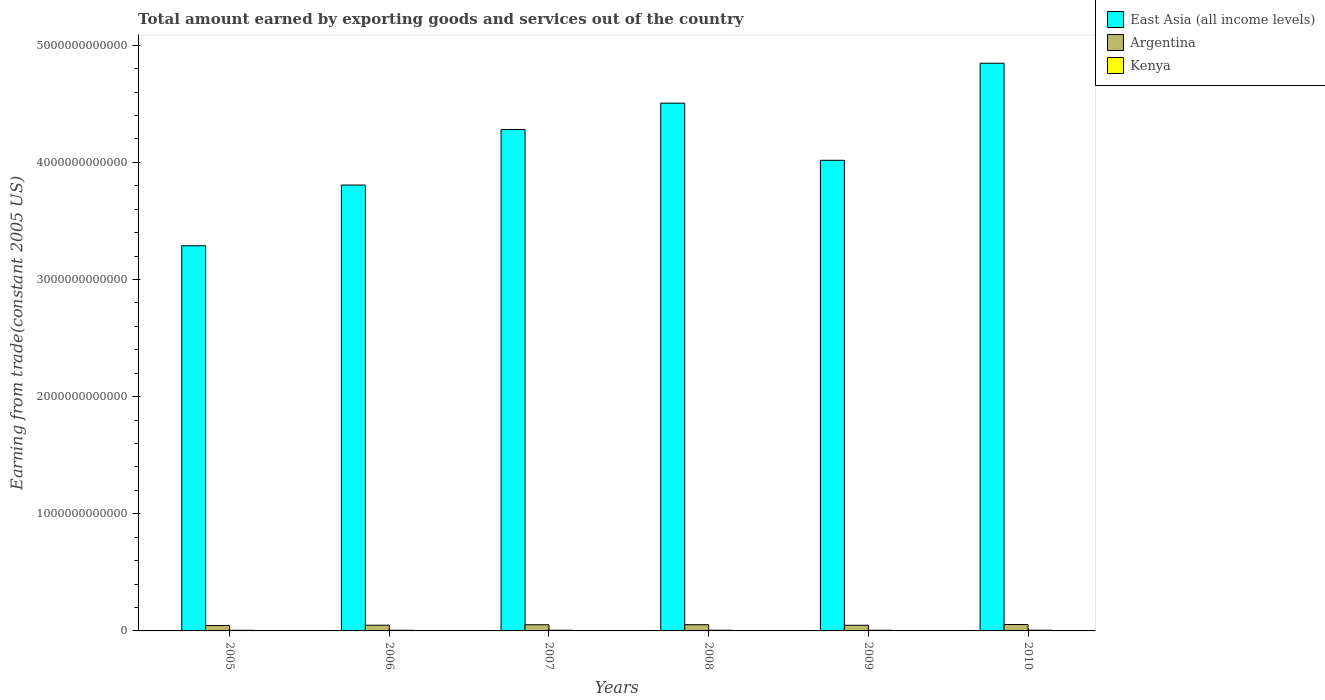How many different coloured bars are there?
Make the answer very short. 3. How many bars are there on the 4th tick from the left?
Offer a very short reply. 3. In how many cases, is the number of bars for a given year not equal to the number of legend labels?
Provide a short and direct response. 0. What is the total amount earned by exporting goods and services in East Asia (all income levels) in 2005?
Give a very brief answer. 3.29e+12. Across all years, what is the maximum total amount earned by exporting goods and services in Kenya?
Your response must be concise. 6.20e+09. Across all years, what is the minimum total amount earned by exporting goods and services in East Asia (all income levels)?
Ensure brevity in your answer.  3.29e+12. In which year was the total amount earned by exporting goods and services in Argentina maximum?
Offer a terse response. 2010. In which year was the total amount earned by exporting goods and services in East Asia (all income levels) minimum?
Offer a terse response. 2005. What is the total total amount earned by exporting goods and services in Kenya in the graph?
Your response must be concise. 3.46e+1. What is the difference between the total amount earned by exporting goods and services in Kenya in 2007 and that in 2008?
Keep it short and to the point. -1.39e+08. What is the difference between the total amount earned by exporting goods and services in Argentina in 2007 and the total amount earned by exporting goods and services in Kenya in 2010?
Provide a short and direct response. 4.64e+1. What is the average total amount earned by exporting goods and services in Kenya per year?
Your answer should be compact. 5.77e+09. In the year 2007, what is the difference between the total amount earned by exporting goods and services in East Asia (all income levels) and total amount earned by exporting goods and services in Argentina?
Keep it short and to the point. 4.23e+12. In how many years, is the total amount earned by exporting goods and services in East Asia (all income levels) greater than 2800000000000 US$?
Your answer should be compact. 6. What is the ratio of the total amount earned by exporting goods and services in Kenya in 2006 to that in 2009?
Offer a terse response. 0.97. What is the difference between the highest and the second highest total amount earned by exporting goods and services in Argentina?
Keep it short and to the point. 1.76e+09. What is the difference between the highest and the lowest total amount earned by exporting goods and services in East Asia (all income levels)?
Your response must be concise. 1.56e+12. Is the sum of the total amount earned by exporting goods and services in East Asia (all income levels) in 2006 and 2009 greater than the maximum total amount earned by exporting goods and services in Argentina across all years?
Ensure brevity in your answer.  Yes. What does the 2nd bar from the left in 2007 represents?
Your answer should be compact. Argentina. What does the 3rd bar from the right in 2007 represents?
Make the answer very short. East Asia (all income levels). How many bars are there?
Ensure brevity in your answer.  18. What is the difference between two consecutive major ticks on the Y-axis?
Your response must be concise. 1.00e+12. Are the values on the major ticks of Y-axis written in scientific E-notation?
Provide a succinct answer. No. How many legend labels are there?
Your answer should be compact. 3. What is the title of the graph?
Offer a very short reply. Total amount earned by exporting goods and services out of the country. What is the label or title of the X-axis?
Offer a terse response. Years. What is the label or title of the Y-axis?
Provide a succinct answer. Earning from trade(constant 2005 US). What is the Earning from trade(constant 2005 US) in East Asia (all income levels) in 2005?
Your response must be concise. 3.29e+12. What is the Earning from trade(constant 2005 US) of Argentina in 2005?
Keep it short and to the point. 4.62e+1. What is the Earning from trade(constant 2005 US) of Kenya in 2005?
Give a very brief answer. 5.34e+09. What is the Earning from trade(constant 2005 US) in East Asia (all income levels) in 2006?
Ensure brevity in your answer.  3.81e+12. What is the Earning from trade(constant 2005 US) of Argentina in 2006?
Keep it short and to the point. 4.88e+1. What is the Earning from trade(constant 2005 US) in Kenya in 2006?
Keep it short and to the point. 5.53e+09. What is the Earning from trade(constant 2005 US) in East Asia (all income levels) in 2007?
Offer a terse response. 4.28e+12. What is the Earning from trade(constant 2005 US) in Argentina in 2007?
Offer a terse response. 5.26e+1. What is the Earning from trade(constant 2005 US) in Kenya in 2007?
Offer a very short reply. 5.87e+09. What is the Earning from trade(constant 2005 US) in East Asia (all income levels) in 2008?
Make the answer very short. 4.51e+12. What is the Earning from trade(constant 2005 US) of Argentina in 2008?
Your answer should be compact. 5.32e+1. What is the Earning from trade(constant 2005 US) of Kenya in 2008?
Your answer should be compact. 6.01e+09. What is the Earning from trade(constant 2005 US) of East Asia (all income levels) in 2009?
Ensure brevity in your answer.  4.02e+12. What is the Earning from trade(constant 2005 US) of Argentina in 2009?
Make the answer very short. 4.82e+1. What is the Earning from trade(constant 2005 US) in Kenya in 2009?
Give a very brief answer. 5.70e+09. What is the Earning from trade(constant 2005 US) of East Asia (all income levels) in 2010?
Provide a short and direct response. 4.85e+12. What is the Earning from trade(constant 2005 US) in Argentina in 2010?
Provide a short and direct response. 5.49e+1. What is the Earning from trade(constant 2005 US) of Kenya in 2010?
Your answer should be compact. 6.20e+09. Across all years, what is the maximum Earning from trade(constant 2005 US) of East Asia (all income levels)?
Give a very brief answer. 4.85e+12. Across all years, what is the maximum Earning from trade(constant 2005 US) of Argentina?
Your answer should be compact. 5.49e+1. Across all years, what is the maximum Earning from trade(constant 2005 US) of Kenya?
Provide a succinct answer. 6.20e+09. Across all years, what is the minimum Earning from trade(constant 2005 US) in East Asia (all income levels)?
Offer a very short reply. 3.29e+12. Across all years, what is the minimum Earning from trade(constant 2005 US) in Argentina?
Ensure brevity in your answer.  4.62e+1. Across all years, what is the minimum Earning from trade(constant 2005 US) of Kenya?
Provide a short and direct response. 5.34e+09. What is the total Earning from trade(constant 2005 US) of East Asia (all income levels) in the graph?
Offer a terse response. 2.47e+13. What is the total Earning from trade(constant 2005 US) of Argentina in the graph?
Provide a succinct answer. 3.04e+11. What is the total Earning from trade(constant 2005 US) in Kenya in the graph?
Your response must be concise. 3.46e+1. What is the difference between the Earning from trade(constant 2005 US) of East Asia (all income levels) in 2005 and that in 2006?
Make the answer very short. -5.18e+11. What is the difference between the Earning from trade(constant 2005 US) of Argentina in 2005 and that in 2006?
Offer a very short reply. -2.61e+09. What is the difference between the Earning from trade(constant 2005 US) of Kenya in 2005 and that in 2006?
Provide a succinct answer. -1.89e+08. What is the difference between the Earning from trade(constant 2005 US) in East Asia (all income levels) in 2005 and that in 2007?
Your response must be concise. -9.92e+11. What is the difference between the Earning from trade(constant 2005 US) in Argentina in 2005 and that in 2007?
Your answer should be very brief. -6.45e+09. What is the difference between the Earning from trade(constant 2005 US) in Kenya in 2005 and that in 2007?
Your response must be concise. -5.30e+08. What is the difference between the Earning from trade(constant 2005 US) in East Asia (all income levels) in 2005 and that in 2008?
Your response must be concise. -1.22e+12. What is the difference between the Earning from trade(constant 2005 US) of Argentina in 2005 and that in 2008?
Keep it short and to the point. -7.02e+09. What is the difference between the Earning from trade(constant 2005 US) of Kenya in 2005 and that in 2008?
Your answer should be compact. -6.69e+08. What is the difference between the Earning from trade(constant 2005 US) of East Asia (all income levels) in 2005 and that in 2009?
Your answer should be very brief. -7.29e+11. What is the difference between the Earning from trade(constant 2005 US) in Argentina in 2005 and that in 2009?
Keep it short and to the point. -2.03e+09. What is the difference between the Earning from trade(constant 2005 US) of Kenya in 2005 and that in 2009?
Provide a short and direct response. -3.55e+08. What is the difference between the Earning from trade(constant 2005 US) of East Asia (all income levels) in 2005 and that in 2010?
Keep it short and to the point. -1.56e+12. What is the difference between the Earning from trade(constant 2005 US) in Argentina in 2005 and that in 2010?
Ensure brevity in your answer.  -8.78e+09. What is the difference between the Earning from trade(constant 2005 US) of Kenya in 2005 and that in 2010?
Your answer should be very brief. -8.53e+08. What is the difference between the Earning from trade(constant 2005 US) of East Asia (all income levels) in 2006 and that in 2007?
Give a very brief answer. -4.74e+11. What is the difference between the Earning from trade(constant 2005 US) of Argentina in 2006 and that in 2007?
Keep it short and to the point. -3.84e+09. What is the difference between the Earning from trade(constant 2005 US) in Kenya in 2006 and that in 2007?
Ensure brevity in your answer.  -3.41e+08. What is the difference between the Earning from trade(constant 2005 US) of East Asia (all income levels) in 2006 and that in 2008?
Provide a succinct answer. -6.99e+11. What is the difference between the Earning from trade(constant 2005 US) of Argentina in 2006 and that in 2008?
Offer a very short reply. -4.41e+09. What is the difference between the Earning from trade(constant 2005 US) of Kenya in 2006 and that in 2008?
Your answer should be compact. -4.80e+08. What is the difference between the Earning from trade(constant 2005 US) in East Asia (all income levels) in 2006 and that in 2009?
Offer a terse response. -2.11e+11. What is the difference between the Earning from trade(constant 2005 US) in Argentina in 2006 and that in 2009?
Ensure brevity in your answer.  5.84e+08. What is the difference between the Earning from trade(constant 2005 US) of Kenya in 2006 and that in 2009?
Offer a very short reply. -1.66e+08. What is the difference between the Earning from trade(constant 2005 US) in East Asia (all income levels) in 2006 and that in 2010?
Your answer should be very brief. -1.04e+12. What is the difference between the Earning from trade(constant 2005 US) of Argentina in 2006 and that in 2010?
Offer a very short reply. -6.17e+09. What is the difference between the Earning from trade(constant 2005 US) of Kenya in 2006 and that in 2010?
Your answer should be compact. -6.64e+08. What is the difference between the Earning from trade(constant 2005 US) in East Asia (all income levels) in 2007 and that in 2008?
Your answer should be compact. -2.25e+11. What is the difference between the Earning from trade(constant 2005 US) in Argentina in 2007 and that in 2008?
Keep it short and to the point. -5.74e+08. What is the difference between the Earning from trade(constant 2005 US) in Kenya in 2007 and that in 2008?
Make the answer very short. -1.39e+08. What is the difference between the Earning from trade(constant 2005 US) in East Asia (all income levels) in 2007 and that in 2009?
Offer a very short reply. 2.62e+11. What is the difference between the Earning from trade(constant 2005 US) in Argentina in 2007 and that in 2009?
Your answer should be very brief. 4.43e+09. What is the difference between the Earning from trade(constant 2005 US) of Kenya in 2007 and that in 2009?
Provide a short and direct response. 1.74e+08. What is the difference between the Earning from trade(constant 2005 US) in East Asia (all income levels) in 2007 and that in 2010?
Give a very brief answer. -5.66e+11. What is the difference between the Earning from trade(constant 2005 US) in Argentina in 2007 and that in 2010?
Give a very brief answer. -2.33e+09. What is the difference between the Earning from trade(constant 2005 US) in Kenya in 2007 and that in 2010?
Keep it short and to the point. -3.24e+08. What is the difference between the Earning from trade(constant 2005 US) in East Asia (all income levels) in 2008 and that in 2009?
Offer a very short reply. 4.88e+11. What is the difference between the Earning from trade(constant 2005 US) of Argentina in 2008 and that in 2009?
Your response must be concise. 5.00e+09. What is the difference between the Earning from trade(constant 2005 US) in Kenya in 2008 and that in 2009?
Offer a terse response. 3.14e+08. What is the difference between the Earning from trade(constant 2005 US) of East Asia (all income levels) in 2008 and that in 2010?
Your response must be concise. -3.41e+11. What is the difference between the Earning from trade(constant 2005 US) in Argentina in 2008 and that in 2010?
Your response must be concise. -1.76e+09. What is the difference between the Earning from trade(constant 2005 US) of Kenya in 2008 and that in 2010?
Make the answer very short. -1.84e+08. What is the difference between the Earning from trade(constant 2005 US) of East Asia (all income levels) in 2009 and that in 2010?
Give a very brief answer. -8.28e+11. What is the difference between the Earning from trade(constant 2005 US) in Argentina in 2009 and that in 2010?
Make the answer very short. -6.76e+09. What is the difference between the Earning from trade(constant 2005 US) in Kenya in 2009 and that in 2010?
Your answer should be very brief. -4.98e+08. What is the difference between the Earning from trade(constant 2005 US) of East Asia (all income levels) in 2005 and the Earning from trade(constant 2005 US) of Argentina in 2006?
Provide a short and direct response. 3.24e+12. What is the difference between the Earning from trade(constant 2005 US) of East Asia (all income levels) in 2005 and the Earning from trade(constant 2005 US) of Kenya in 2006?
Your response must be concise. 3.28e+12. What is the difference between the Earning from trade(constant 2005 US) of Argentina in 2005 and the Earning from trade(constant 2005 US) of Kenya in 2006?
Keep it short and to the point. 4.06e+1. What is the difference between the Earning from trade(constant 2005 US) of East Asia (all income levels) in 2005 and the Earning from trade(constant 2005 US) of Argentina in 2007?
Your answer should be very brief. 3.24e+12. What is the difference between the Earning from trade(constant 2005 US) of East Asia (all income levels) in 2005 and the Earning from trade(constant 2005 US) of Kenya in 2007?
Provide a succinct answer. 3.28e+12. What is the difference between the Earning from trade(constant 2005 US) of Argentina in 2005 and the Earning from trade(constant 2005 US) of Kenya in 2007?
Your answer should be compact. 4.03e+1. What is the difference between the Earning from trade(constant 2005 US) in East Asia (all income levels) in 2005 and the Earning from trade(constant 2005 US) in Argentina in 2008?
Your answer should be very brief. 3.24e+12. What is the difference between the Earning from trade(constant 2005 US) of East Asia (all income levels) in 2005 and the Earning from trade(constant 2005 US) of Kenya in 2008?
Offer a terse response. 3.28e+12. What is the difference between the Earning from trade(constant 2005 US) of Argentina in 2005 and the Earning from trade(constant 2005 US) of Kenya in 2008?
Give a very brief answer. 4.01e+1. What is the difference between the Earning from trade(constant 2005 US) of East Asia (all income levels) in 2005 and the Earning from trade(constant 2005 US) of Argentina in 2009?
Offer a very short reply. 3.24e+12. What is the difference between the Earning from trade(constant 2005 US) in East Asia (all income levels) in 2005 and the Earning from trade(constant 2005 US) in Kenya in 2009?
Your answer should be very brief. 3.28e+12. What is the difference between the Earning from trade(constant 2005 US) of Argentina in 2005 and the Earning from trade(constant 2005 US) of Kenya in 2009?
Your response must be concise. 4.05e+1. What is the difference between the Earning from trade(constant 2005 US) in East Asia (all income levels) in 2005 and the Earning from trade(constant 2005 US) in Argentina in 2010?
Keep it short and to the point. 3.23e+12. What is the difference between the Earning from trade(constant 2005 US) of East Asia (all income levels) in 2005 and the Earning from trade(constant 2005 US) of Kenya in 2010?
Offer a very short reply. 3.28e+12. What is the difference between the Earning from trade(constant 2005 US) in Argentina in 2005 and the Earning from trade(constant 2005 US) in Kenya in 2010?
Your answer should be very brief. 4.00e+1. What is the difference between the Earning from trade(constant 2005 US) in East Asia (all income levels) in 2006 and the Earning from trade(constant 2005 US) in Argentina in 2007?
Your answer should be very brief. 3.75e+12. What is the difference between the Earning from trade(constant 2005 US) of East Asia (all income levels) in 2006 and the Earning from trade(constant 2005 US) of Kenya in 2007?
Your answer should be very brief. 3.80e+12. What is the difference between the Earning from trade(constant 2005 US) in Argentina in 2006 and the Earning from trade(constant 2005 US) in Kenya in 2007?
Provide a succinct answer. 4.29e+1. What is the difference between the Earning from trade(constant 2005 US) in East Asia (all income levels) in 2006 and the Earning from trade(constant 2005 US) in Argentina in 2008?
Offer a very short reply. 3.75e+12. What is the difference between the Earning from trade(constant 2005 US) in East Asia (all income levels) in 2006 and the Earning from trade(constant 2005 US) in Kenya in 2008?
Offer a terse response. 3.80e+12. What is the difference between the Earning from trade(constant 2005 US) of Argentina in 2006 and the Earning from trade(constant 2005 US) of Kenya in 2008?
Your response must be concise. 4.28e+1. What is the difference between the Earning from trade(constant 2005 US) in East Asia (all income levels) in 2006 and the Earning from trade(constant 2005 US) in Argentina in 2009?
Offer a very short reply. 3.76e+12. What is the difference between the Earning from trade(constant 2005 US) of East Asia (all income levels) in 2006 and the Earning from trade(constant 2005 US) of Kenya in 2009?
Offer a terse response. 3.80e+12. What is the difference between the Earning from trade(constant 2005 US) in Argentina in 2006 and the Earning from trade(constant 2005 US) in Kenya in 2009?
Your answer should be very brief. 4.31e+1. What is the difference between the Earning from trade(constant 2005 US) in East Asia (all income levels) in 2006 and the Earning from trade(constant 2005 US) in Argentina in 2010?
Offer a very short reply. 3.75e+12. What is the difference between the Earning from trade(constant 2005 US) of East Asia (all income levels) in 2006 and the Earning from trade(constant 2005 US) of Kenya in 2010?
Your response must be concise. 3.80e+12. What is the difference between the Earning from trade(constant 2005 US) of Argentina in 2006 and the Earning from trade(constant 2005 US) of Kenya in 2010?
Give a very brief answer. 4.26e+1. What is the difference between the Earning from trade(constant 2005 US) of East Asia (all income levels) in 2007 and the Earning from trade(constant 2005 US) of Argentina in 2008?
Give a very brief answer. 4.23e+12. What is the difference between the Earning from trade(constant 2005 US) of East Asia (all income levels) in 2007 and the Earning from trade(constant 2005 US) of Kenya in 2008?
Make the answer very short. 4.27e+12. What is the difference between the Earning from trade(constant 2005 US) of Argentina in 2007 and the Earning from trade(constant 2005 US) of Kenya in 2008?
Your answer should be very brief. 4.66e+1. What is the difference between the Earning from trade(constant 2005 US) in East Asia (all income levels) in 2007 and the Earning from trade(constant 2005 US) in Argentina in 2009?
Offer a very short reply. 4.23e+12. What is the difference between the Earning from trade(constant 2005 US) in East Asia (all income levels) in 2007 and the Earning from trade(constant 2005 US) in Kenya in 2009?
Provide a succinct answer. 4.27e+12. What is the difference between the Earning from trade(constant 2005 US) in Argentina in 2007 and the Earning from trade(constant 2005 US) in Kenya in 2009?
Your answer should be compact. 4.69e+1. What is the difference between the Earning from trade(constant 2005 US) in East Asia (all income levels) in 2007 and the Earning from trade(constant 2005 US) in Argentina in 2010?
Your answer should be very brief. 4.23e+12. What is the difference between the Earning from trade(constant 2005 US) of East Asia (all income levels) in 2007 and the Earning from trade(constant 2005 US) of Kenya in 2010?
Provide a succinct answer. 4.27e+12. What is the difference between the Earning from trade(constant 2005 US) in Argentina in 2007 and the Earning from trade(constant 2005 US) in Kenya in 2010?
Provide a short and direct response. 4.64e+1. What is the difference between the Earning from trade(constant 2005 US) in East Asia (all income levels) in 2008 and the Earning from trade(constant 2005 US) in Argentina in 2009?
Make the answer very short. 4.46e+12. What is the difference between the Earning from trade(constant 2005 US) of East Asia (all income levels) in 2008 and the Earning from trade(constant 2005 US) of Kenya in 2009?
Make the answer very short. 4.50e+12. What is the difference between the Earning from trade(constant 2005 US) of Argentina in 2008 and the Earning from trade(constant 2005 US) of Kenya in 2009?
Ensure brevity in your answer.  4.75e+1. What is the difference between the Earning from trade(constant 2005 US) of East Asia (all income levels) in 2008 and the Earning from trade(constant 2005 US) of Argentina in 2010?
Your response must be concise. 4.45e+12. What is the difference between the Earning from trade(constant 2005 US) of East Asia (all income levels) in 2008 and the Earning from trade(constant 2005 US) of Kenya in 2010?
Ensure brevity in your answer.  4.50e+12. What is the difference between the Earning from trade(constant 2005 US) of Argentina in 2008 and the Earning from trade(constant 2005 US) of Kenya in 2010?
Ensure brevity in your answer.  4.70e+1. What is the difference between the Earning from trade(constant 2005 US) of East Asia (all income levels) in 2009 and the Earning from trade(constant 2005 US) of Argentina in 2010?
Give a very brief answer. 3.96e+12. What is the difference between the Earning from trade(constant 2005 US) of East Asia (all income levels) in 2009 and the Earning from trade(constant 2005 US) of Kenya in 2010?
Give a very brief answer. 4.01e+12. What is the difference between the Earning from trade(constant 2005 US) of Argentina in 2009 and the Earning from trade(constant 2005 US) of Kenya in 2010?
Keep it short and to the point. 4.20e+1. What is the average Earning from trade(constant 2005 US) in East Asia (all income levels) per year?
Your answer should be compact. 4.12e+12. What is the average Earning from trade(constant 2005 US) of Argentina per year?
Keep it short and to the point. 5.06e+1. What is the average Earning from trade(constant 2005 US) in Kenya per year?
Keep it short and to the point. 5.77e+09. In the year 2005, what is the difference between the Earning from trade(constant 2005 US) of East Asia (all income levels) and Earning from trade(constant 2005 US) of Argentina?
Your answer should be very brief. 3.24e+12. In the year 2005, what is the difference between the Earning from trade(constant 2005 US) of East Asia (all income levels) and Earning from trade(constant 2005 US) of Kenya?
Give a very brief answer. 3.28e+12. In the year 2005, what is the difference between the Earning from trade(constant 2005 US) of Argentina and Earning from trade(constant 2005 US) of Kenya?
Make the answer very short. 4.08e+1. In the year 2006, what is the difference between the Earning from trade(constant 2005 US) in East Asia (all income levels) and Earning from trade(constant 2005 US) in Argentina?
Keep it short and to the point. 3.76e+12. In the year 2006, what is the difference between the Earning from trade(constant 2005 US) in East Asia (all income levels) and Earning from trade(constant 2005 US) in Kenya?
Your answer should be compact. 3.80e+12. In the year 2006, what is the difference between the Earning from trade(constant 2005 US) in Argentina and Earning from trade(constant 2005 US) in Kenya?
Your answer should be very brief. 4.32e+1. In the year 2007, what is the difference between the Earning from trade(constant 2005 US) of East Asia (all income levels) and Earning from trade(constant 2005 US) of Argentina?
Your response must be concise. 4.23e+12. In the year 2007, what is the difference between the Earning from trade(constant 2005 US) in East Asia (all income levels) and Earning from trade(constant 2005 US) in Kenya?
Your response must be concise. 4.27e+12. In the year 2007, what is the difference between the Earning from trade(constant 2005 US) in Argentina and Earning from trade(constant 2005 US) in Kenya?
Give a very brief answer. 4.67e+1. In the year 2008, what is the difference between the Earning from trade(constant 2005 US) of East Asia (all income levels) and Earning from trade(constant 2005 US) of Argentina?
Provide a short and direct response. 4.45e+12. In the year 2008, what is the difference between the Earning from trade(constant 2005 US) in East Asia (all income levels) and Earning from trade(constant 2005 US) in Kenya?
Offer a terse response. 4.50e+12. In the year 2008, what is the difference between the Earning from trade(constant 2005 US) of Argentina and Earning from trade(constant 2005 US) of Kenya?
Provide a succinct answer. 4.72e+1. In the year 2009, what is the difference between the Earning from trade(constant 2005 US) of East Asia (all income levels) and Earning from trade(constant 2005 US) of Argentina?
Provide a short and direct response. 3.97e+12. In the year 2009, what is the difference between the Earning from trade(constant 2005 US) of East Asia (all income levels) and Earning from trade(constant 2005 US) of Kenya?
Make the answer very short. 4.01e+12. In the year 2009, what is the difference between the Earning from trade(constant 2005 US) in Argentina and Earning from trade(constant 2005 US) in Kenya?
Your answer should be compact. 4.25e+1. In the year 2010, what is the difference between the Earning from trade(constant 2005 US) of East Asia (all income levels) and Earning from trade(constant 2005 US) of Argentina?
Your answer should be compact. 4.79e+12. In the year 2010, what is the difference between the Earning from trade(constant 2005 US) in East Asia (all income levels) and Earning from trade(constant 2005 US) in Kenya?
Your answer should be compact. 4.84e+12. In the year 2010, what is the difference between the Earning from trade(constant 2005 US) in Argentina and Earning from trade(constant 2005 US) in Kenya?
Provide a short and direct response. 4.87e+1. What is the ratio of the Earning from trade(constant 2005 US) in East Asia (all income levels) in 2005 to that in 2006?
Offer a very short reply. 0.86. What is the ratio of the Earning from trade(constant 2005 US) of Argentina in 2005 to that in 2006?
Provide a short and direct response. 0.95. What is the ratio of the Earning from trade(constant 2005 US) in Kenya in 2005 to that in 2006?
Offer a very short reply. 0.97. What is the ratio of the Earning from trade(constant 2005 US) of East Asia (all income levels) in 2005 to that in 2007?
Provide a succinct answer. 0.77. What is the ratio of the Earning from trade(constant 2005 US) in Argentina in 2005 to that in 2007?
Provide a short and direct response. 0.88. What is the ratio of the Earning from trade(constant 2005 US) in Kenya in 2005 to that in 2007?
Give a very brief answer. 0.91. What is the ratio of the Earning from trade(constant 2005 US) of East Asia (all income levels) in 2005 to that in 2008?
Offer a very short reply. 0.73. What is the ratio of the Earning from trade(constant 2005 US) in Argentina in 2005 to that in 2008?
Your response must be concise. 0.87. What is the ratio of the Earning from trade(constant 2005 US) in Kenya in 2005 to that in 2008?
Your response must be concise. 0.89. What is the ratio of the Earning from trade(constant 2005 US) of East Asia (all income levels) in 2005 to that in 2009?
Your response must be concise. 0.82. What is the ratio of the Earning from trade(constant 2005 US) of Argentina in 2005 to that in 2009?
Give a very brief answer. 0.96. What is the ratio of the Earning from trade(constant 2005 US) in Kenya in 2005 to that in 2009?
Offer a terse response. 0.94. What is the ratio of the Earning from trade(constant 2005 US) of East Asia (all income levels) in 2005 to that in 2010?
Give a very brief answer. 0.68. What is the ratio of the Earning from trade(constant 2005 US) in Argentina in 2005 to that in 2010?
Provide a short and direct response. 0.84. What is the ratio of the Earning from trade(constant 2005 US) in Kenya in 2005 to that in 2010?
Keep it short and to the point. 0.86. What is the ratio of the Earning from trade(constant 2005 US) of East Asia (all income levels) in 2006 to that in 2007?
Your response must be concise. 0.89. What is the ratio of the Earning from trade(constant 2005 US) in Argentina in 2006 to that in 2007?
Ensure brevity in your answer.  0.93. What is the ratio of the Earning from trade(constant 2005 US) in Kenya in 2006 to that in 2007?
Give a very brief answer. 0.94. What is the ratio of the Earning from trade(constant 2005 US) of East Asia (all income levels) in 2006 to that in 2008?
Make the answer very short. 0.84. What is the ratio of the Earning from trade(constant 2005 US) of Argentina in 2006 to that in 2008?
Provide a short and direct response. 0.92. What is the ratio of the Earning from trade(constant 2005 US) of Kenya in 2006 to that in 2008?
Provide a succinct answer. 0.92. What is the ratio of the Earning from trade(constant 2005 US) in East Asia (all income levels) in 2006 to that in 2009?
Your answer should be very brief. 0.95. What is the ratio of the Earning from trade(constant 2005 US) in Argentina in 2006 to that in 2009?
Provide a short and direct response. 1.01. What is the ratio of the Earning from trade(constant 2005 US) of Kenya in 2006 to that in 2009?
Provide a short and direct response. 0.97. What is the ratio of the Earning from trade(constant 2005 US) in East Asia (all income levels) in 2006 to that in 2010?
Your answer should be very brief. 0.79. What is the ratio of the Earning from trade(constant 2005 US) in Argentina in 2006 to that in 2010?
Offer a very short reply. 0.89. What is the ratio of the Earning from trade(constant 2005 US) in Kenya in 2006 to that in 2010?
Ensure brevity in your answer.  0.89. What is the ratio of the Earning from trade(constant 2005 US) of Argentina in 2007 to that in 2008?
Your response must be concise. 0.99. What is the ratio of the Earning from trade(constant 2005 US) in Kenya in 2007 to that in 2008?
Your response must be concise. 0.98. What is the ratio of the Earning from trade(constant 2005 US) of East Asia (all income levels) in 2007 to that in 2009?
Offer a terse response. 1.07. What is the ratio of the Earning from trade(constant 2005 US) of Argentina in 2007 to that in 2009?
Provide a short and direct response. 1.09. What is the ratio of the Earning from trade(constant 2005 US) in Kenya in 2007 to that in 2009?
Provide a short and direct response. 1.03. What is the ratio of the Earning from trade(constant 2005 US) in East Asia (all income levels) in 2007 to that in 2010?
Your answer should be very brief. 0.88. What is the ratio of the Earning from trade(constant 2005 US) in Argentina in 2007 to that in 2010?
Make the answer very short. 0.96. What is the ratio of the Earning from trade(constant 2005 US) of Kenya in 2007 to that in 2010?
Your answer should be very brief. 0.95. What is the ratio of the Earning from trade(constant 2005 US) in East Asia (all income levels) in 2008 to that in 2009?
Your answer should be very brief. 1.12. What is the ratio of the Earning from trade(constant 2005 US) in Argentina in 2008 to that in 2009?
Provide a succinct answer. 1.1. What is the ratio of the Earning from trade(constant 2005 US) in Kenya in 2008 to that in 2009?
Your answer should be compact. 1.06. What is the ratio of the Earning from trade(constant 2005 US) in East Asia (all income levels) in 2008 to that in 2010?
Your answer should be very brief. 0.93. What is the ratio of the Earning from trade(constant 2005 US) of Argentina in 2008 to that in 2010?
Keep it short and to the point. 0.97. What is the ratio of the Earning from trade(constant 2005 US) in Kenya in 2008 to that in 2010?
Offer a terse response. 0.97. What is the ratio of the Earning from trade(constant 2005 US) in East Asia (all income levels) in 2009 to that in 2010?
Ensure brevity in your answer.  0.83. What is the ratio of the Earning from trade(constant 2005 US) in Argentina in 2009 to that in 2010?
Offer a very short reply. 0.88. What is the ratio of the Earning from trade(constant 2005 US) of Kenya in 2009 to that in 2010?
Provide a succinct answer. 0.92. What is the difference between the highest and the second highest Earning from trade(constant 2005 US) of East Asia (all income levels)?
Give a very brief answer. 3.41e+11. What is the difference between the highest and the second highest Earning from trade(constant 2005 US) in Argentina?
Provide a succinct answer. 1.76e+09. What is the difference between the highest and the second highest Earning from trade(constant 2005 US) in Kenya?
Give a very brief answer. 1.84e+08. What is the difference between the highest and the lowest Earning from trade(constant 2005 US) in East Asia (all income levels)?
Provide a succinct answer. 1.56e+12. What is the difference between the highest and the lowest Earning from trade(constant 2005 US) in Argentina?
Make the answer very short. 8.78e+09. What is the difference between the highest and the lowest Earning from trade(constant 2005 US) in Kenya?
Make the answer very short. 8.53e+08. 